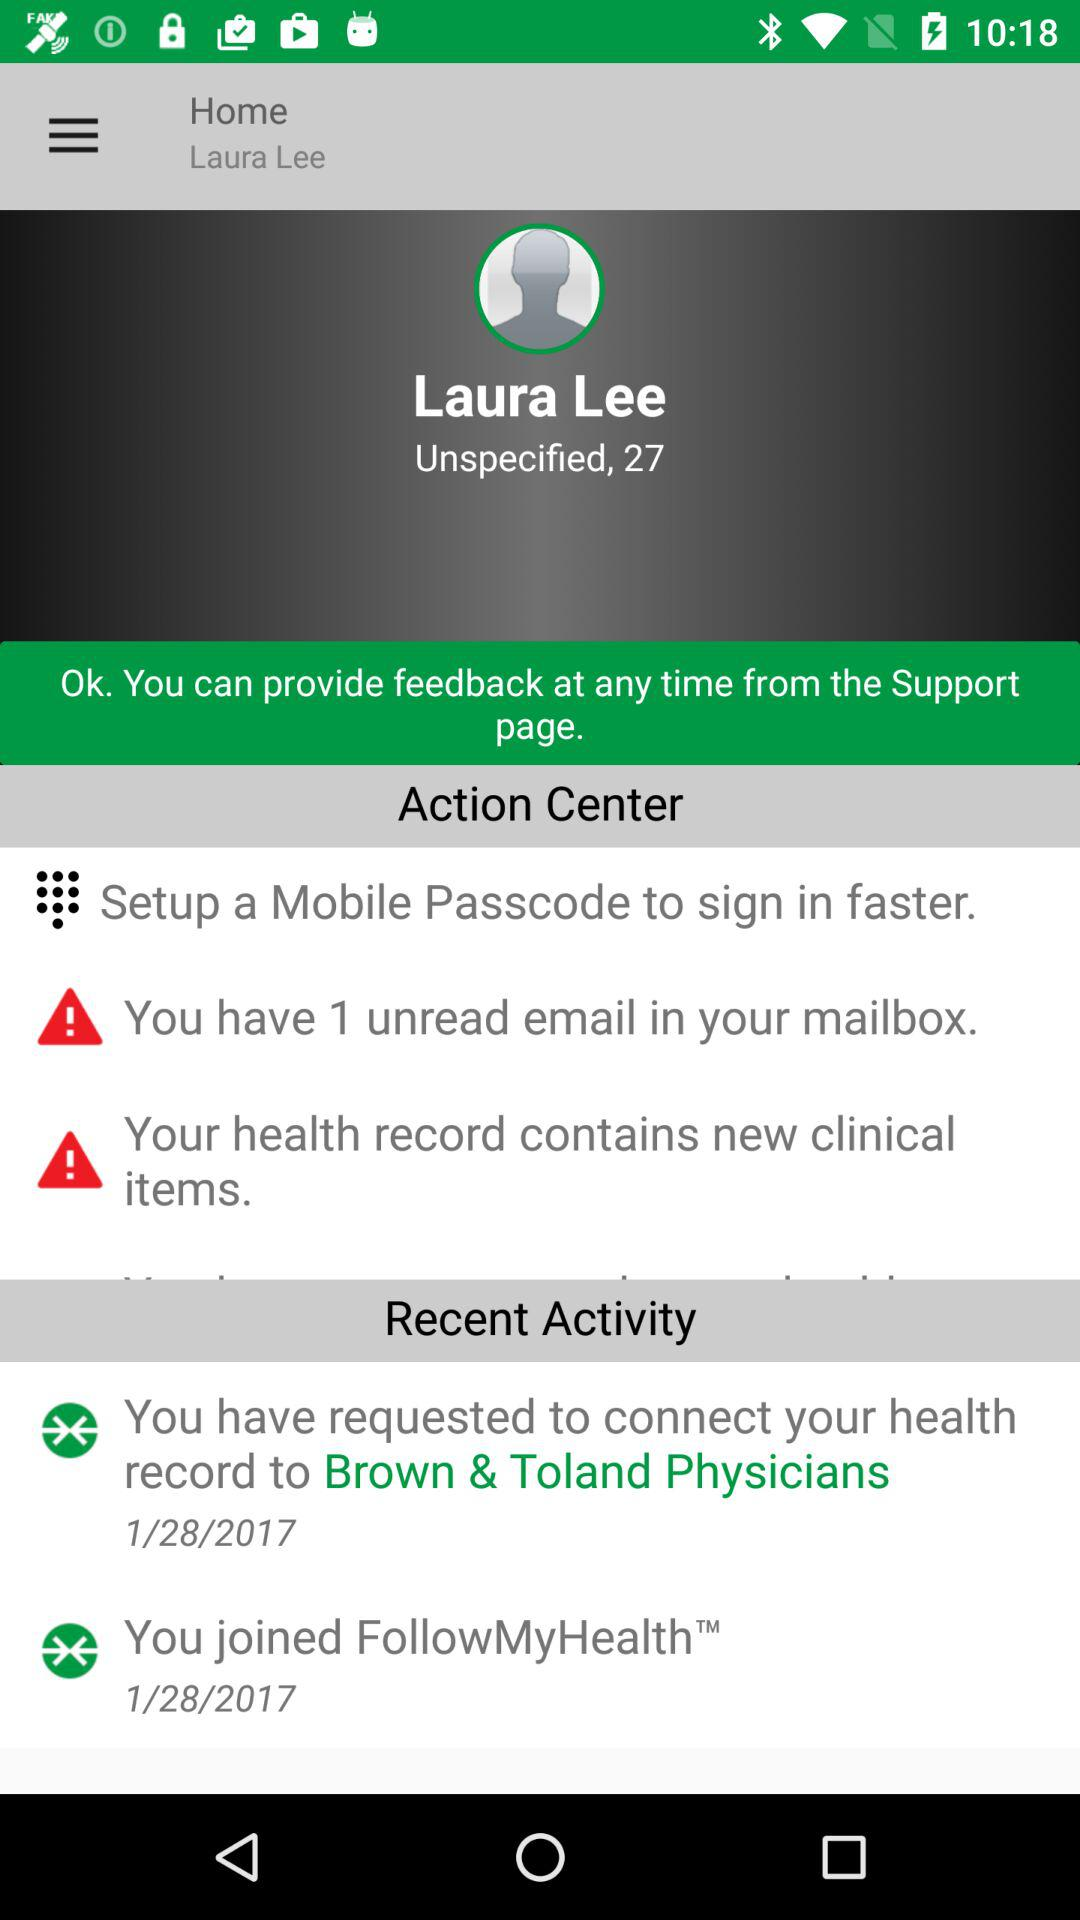How many unread emails does the user have?
Answer the question using a single word or phrase. 1 